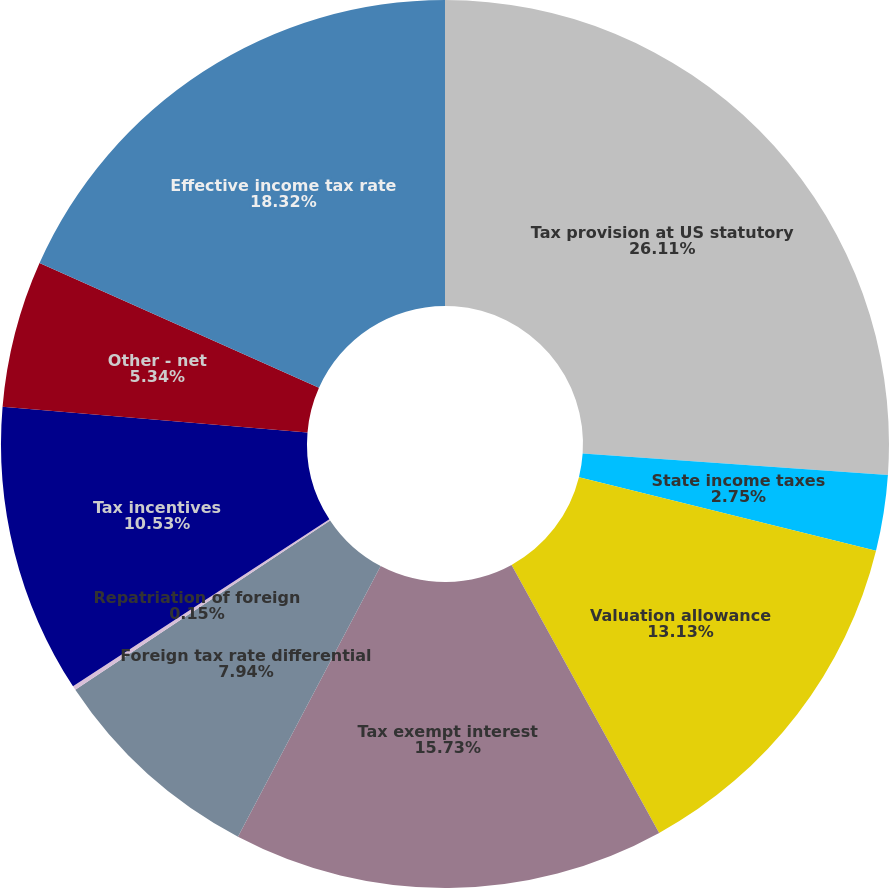Convert chart to OTSL. <chart><loc_0><loc_0><loc_500><loc_500><pie_chart><fcel>Tax provision at US statutory<fcel>State income taxes<fcel>Valuation allowance<fcel>Tax exempt interest<fcel>Foreign tax rate differential<fcel>Repatriation of foreign<fcel>Tax incentives<fcel>Other - net<fcel>Effective income tax rate<nl><fcel>26.11%<fcel>2.75%<fcel>13.13%<fcel>15.73%<fcel>7.94%<fcel>0.15%<fcel>10.53%<fcel>5.34%<fcel>18.32%<nl></chart> 